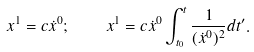Convert formula to latex. <formula><loc_0><loc_0><loc_500><loc_500>x ^ { 1 } = c \dot { x } ^ { 0 } ; \quad x ^ { 1 } = c \dot { x } ^ { 0 } \int _ { t _ { 0 } } ^ { t } \frac { 1 } { ( \dot { x } ^ { 0 } ) ^ { 2 } } d t ^ { \prime } .</formula> 